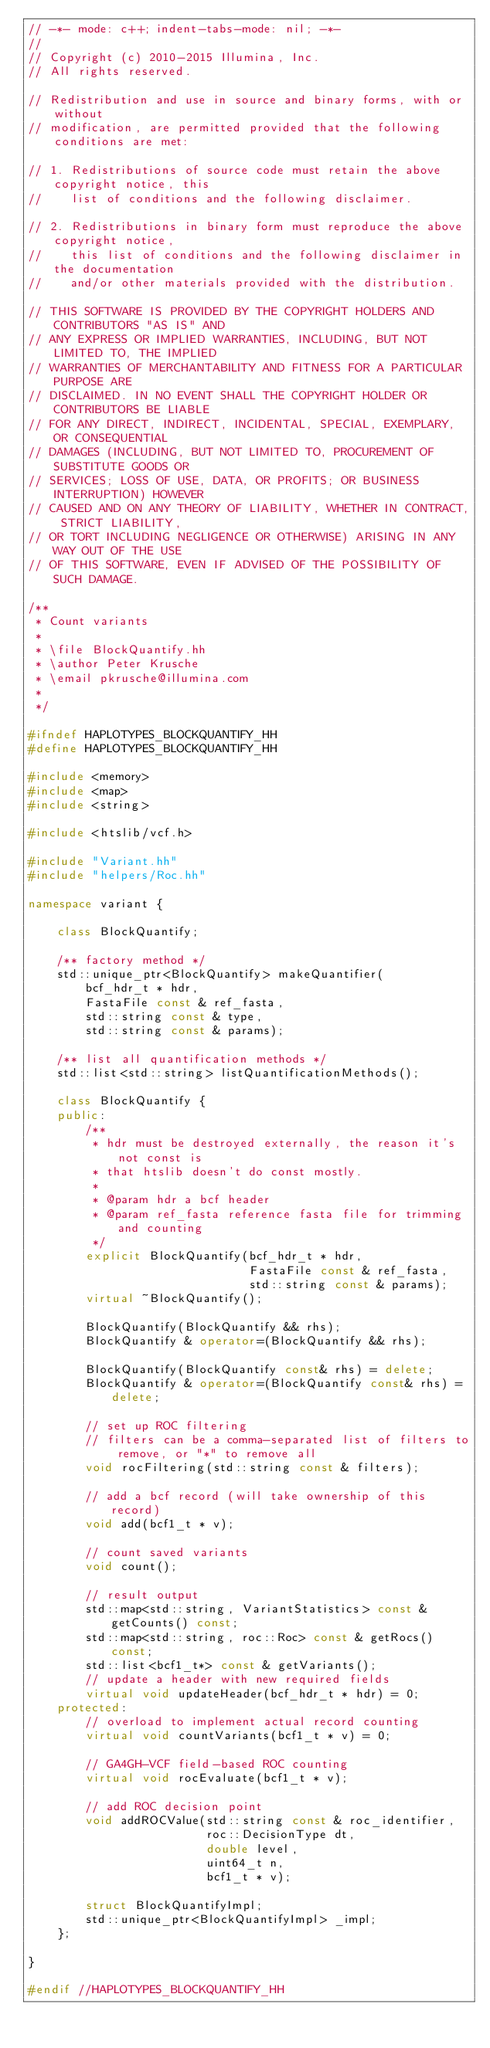Convert code to text. <code><loc_0><loc_0><loc_500><loc_500><_C++_>// -*- mode: c++; indent-tabs-mode: nil; -*-
//
// Copyright (c) 2010-2015 Illumina, Inc.
// All rights reserved.

// Redistribution and use in source and binary forms, with or without
// modification, are permitted provided that the following conditions are met:

// 1. Redistributions of source code must retain the above copyright notice, this
//    list of conditions and the following disclaimer.

// 2. Redistributions in binary form must reproduce the above copyright notice,
//    this list of conditions and the following disclaimer in the documentation
//    and/or other materials provided with the distribution.

// THIS SOFTWARE IS PROVIDED BY THE COPYRIGHT HOLDERS AND CONTRIBUTORS "AS IS" AND
// ANY EXPRESS OR IMPLIED WARRANTIES, INCLUDING, BUT NOT LIMITED TO, THE IMPLIED
// WARRANTIES OF MERCHANTABILITY AND FITNESS FOR A PARTICULAR PURPOSE ARE
// DISCLAIMED. IN NO EVENT SHALL THE COPYRIGHT HOLDER OR CONTRIBUTORS BE LIABLE
// FOR ANY DIRECT, INDIRECT, INCIDENTAL, SPECIAL, EXEMPLARY, OR CONSEQUENTIAL
// DAMAGES (INCLUDING, BUT NOT LIMITED TO, PROCUREMENT OF SUBSTITUTE GOODS OR
// SERVICES; LOSS OF USE, DATA, OR PROFITS; OR BUSINESS INTERRUPTION) HOWEVER
// CAUSED AND ON ANY THEORY OF LIABILITY, WHETHER IN CONTRACT, STRICT LIABILITY,
// OR TORT INCLUDING NEGLIGENCE OR OTHERWISE) ARISING IN ANY WAY OUT OF THE USE
// OF THIS SOFTWARE, EVEN IF ADVISED OF THE POSSIBILITY OF SUCH DAMAGE.

/**
 * Count variants
 *
 * \file BlockQuantify.hh
 * \author Peter Krusche
 * \email pkrusche@illumina.com
 *
 */

#ifndef HAPLOTYPES_BLOCKQUANTIFY_HH
#define HAPLOTYPES_BLOCKQUANTIFY_HH

#include <memory>
#include <map>
#include <string>

#include <htslib/vcf.h>

#include "Variant.hh"
#include "helpers/Roc.hh"

namespace variant {

    class BlockQuantify;

    /** factory method */
    std::unique_ptr<BlockQuantify> makeQuantifier(
        bcf_hdr_t * hdr,
        FastaFile const & ref_fasta,
        std::string const & type,
        std::string const & params);

    /** list all quantification methods */
    std::list<std::string> listQuantificationMethods();

    class BlockQuantify {
    public:
        /**
         * hdr must be destroyed externally, the reason it's not const is
         * that htslib doesn't do const mostly.
         *
         * @param hdr a bcf header
         * @param ref_fasta reference fasta file for trimming and counting
         */
        explicit BlockQuantify(bcf_hdr_t * hdr,
                               FastaFile const & ref_fasta,
                               std::string const & params);
        virtual ~BlockQuantify();

        BlockQuantify(BlockQuantify && rhs);
        BlockQuantify & operator=(BlockQuantify && rhs);

        BlockQuantify(BlockQuantify const& rhs) = delete;
        BlockQuantify & operator=(BlockQuantify const& rhs) = delete;

        // set up ROC filtering
        // filters can be a comma-separated list of filters to remove, or "*" to remove all
        void rocFiltering(std::string const & filters);

        // add a bcf record (will take ownership of this record)
        void add(bcf1_t * v);

        // count saved variants
        void count();

        // result output
        std::map<std::string, VariantStatistics> const & getCounts() const;
        std::map<std::string, roc::Roc> const & getRocs() const;
        std::list<bcf1_t*> const & getVariants();
        // update a header with new required fields
        virtual void updateHeader(bcf_hdr_t * hdr) = 0;
    protected:
        // overload to implement actual record counting
        virtual void countVariants(bcf1_t * v) = 0;

        // GA4GH-VCF field-based ROC counting
        virtual void rocEvaluate(bcf1_t * v);

        // add ROC decision point
        void addROCValue(std::string const & roc_identifier,
                         roc::DecisionType dt,
                         double level,
                         uint64_t n,
                         bcf1_t * v);

        struct BlockQuantifyImpl;
        std::unique_ptr<BlockQuantifyImpl> _impl;
    };

}

#endif //HAPLOTYPES_BLOCKQUANTIFY_HH
</code> 